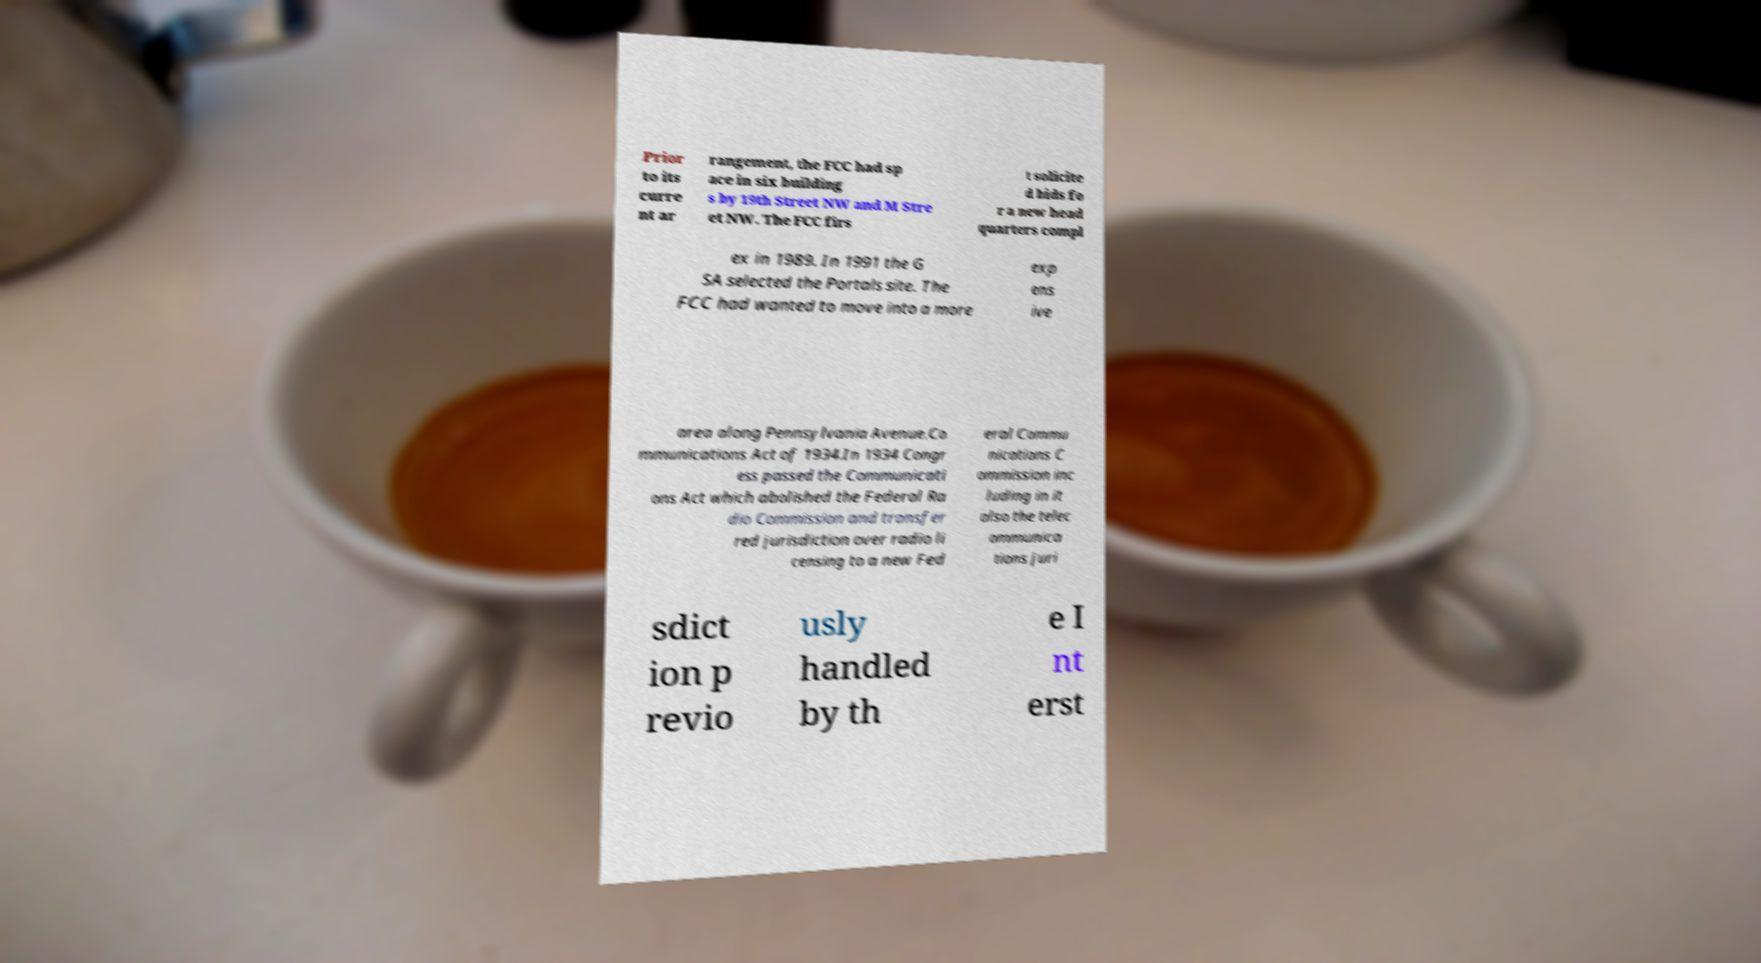Could you extract and type out the text from this image? Prior to its curre nt ar rangement, the FCC had sp ace in six building s by 19th Street NW and M Stre et NW. The FCC firs t solicite d bids fo r a new head quarters compl ex in 1989. In 1991 the G SA selected the Portals site. The FCC had wanted to move into a more exp ens ive area along Pennsylvania Avenue.Co mmunications Act of 1934.In 1934 Congr ess passed the Communicati ons Act which abolished the Federal Ra dio Commission and transfer red jurisdiction over radio li censing to a new Fed eral Commu nications C ommission inc luding in it also the telec ommunica tions juri sdict ion p revio usly handled by th e I nt erst 